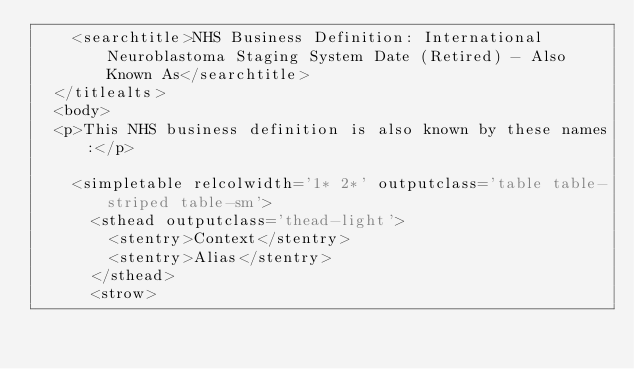Convert code to text. <code><loc_0><loc_0><loc_500><loc_500><_XML_>    <searchtitle>NHS Business Definition: International Neuroblastoma Staging System Date (Retired) - Also Known As</searchtitle>
  </titlealts>
  <body>
  <p>This NHS business definition is also known by these names:</p>

    <simpletable relcolwidth='1* 2*' outputclass='table table-striped table-sm'>
      <sthead outputclass='thead-light'>
        <stentry>Context</stentry>
        <stentry>Alias</stentry>
      </sthead>
      <strow></code> 